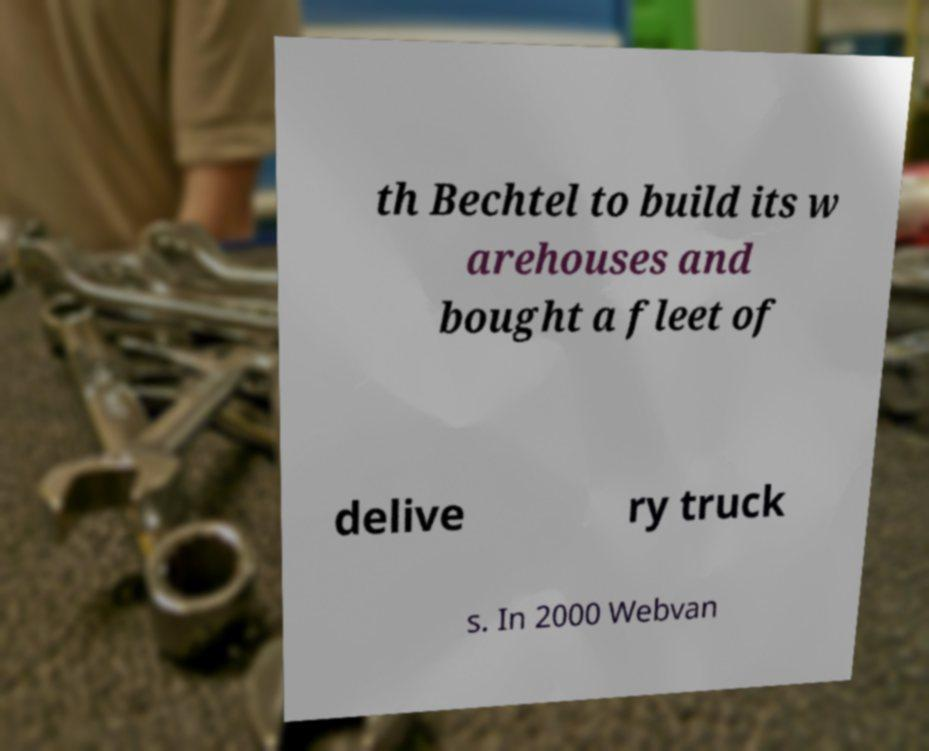Could you extract and type out the text from this image? th Bechtel to build its w arehouses and bought a fleet of delive ry truck s. In 2000 Webvan 